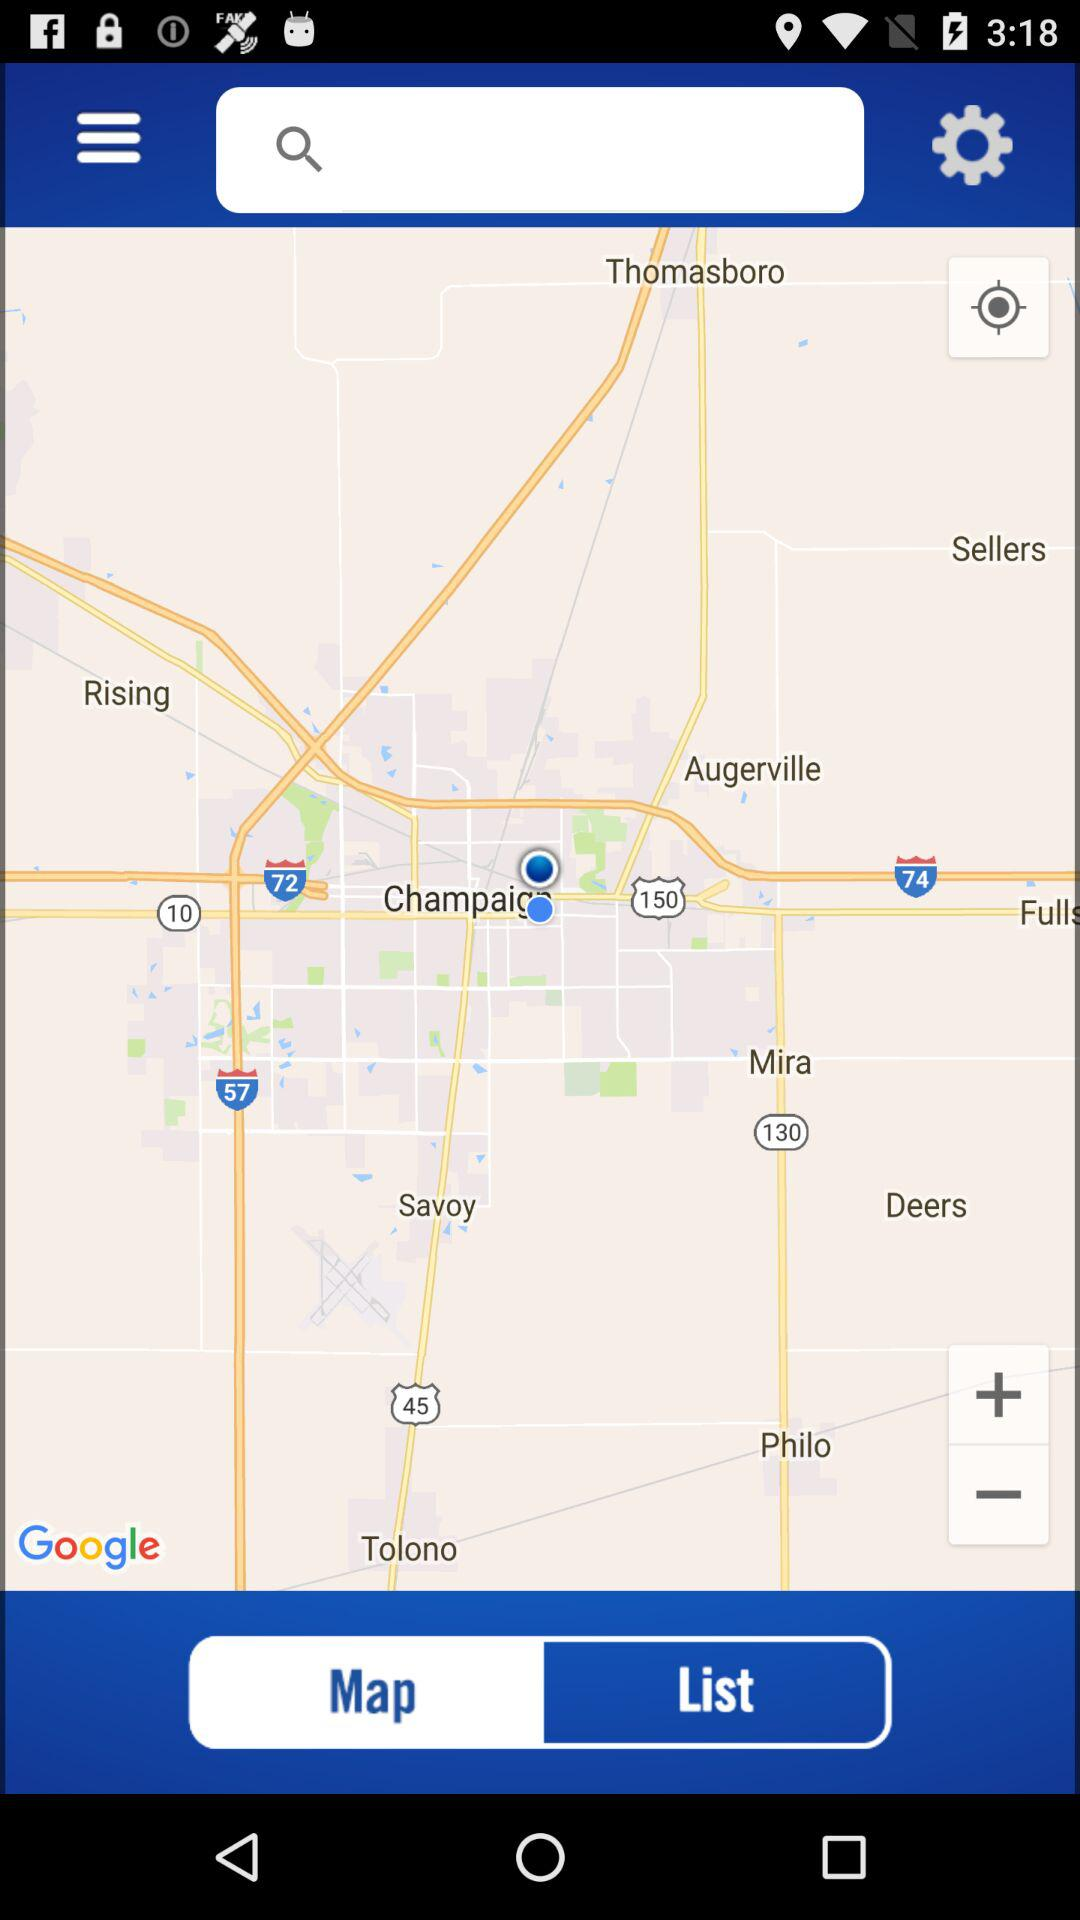What is the selected tab? The selected tab is "Map". 